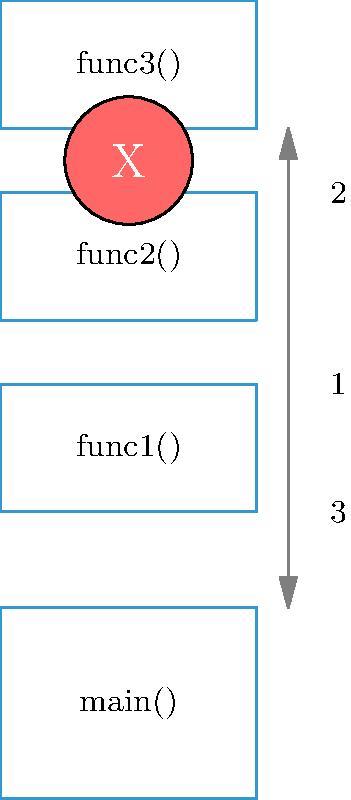In the context of exception handling and stack unwinding, analyze the vector diagram provided. Which statement best describes the process illustrated?

A) The exception is caught and handled in func1()
B) The stack unwinds from func3() directly to main()
C) The exception propagates through func2() and func1() before being caught
D) Stack unwinding occurs, but the exception remains unhandled To understand the stack unwinding process during exception handling as illustrated in the diagram, let's break it down step-by-step:

1. The diagram shows a call stack with four functions: main(), func1(), func2(), and func3().

2. The exception (represented by the red circle with "X") occurs in func3(), which is at the top of the call stack.

3. The arrows on the right side of the diagram indicate the direction of the stack unwinding process:
   - Arrow 1 shows the initial function calls from main() to func3().
   - Arrows 2 and 3 show the stack unwinding process after the exception occurs.

4. When the exception is thrown in func3(), the stack begins to unwind. This means that the program looks for an appropriate exception handler by moving down the call stack.

5. The diagram shows that the exception propagates through func2() and func1(). This is evident from the continuous downward arrow (labeled 2) passing through these functions.

6. The stack unwinding process continues until it reaches main(), as indicated by arrow 3.

7. There is no indication in the diagram of the exception being caught and handled in any of the intermediate functions (func2() or func1()).

8. The diagram doesn't explicitly show where the exception is ultimately handled, but it demonstrates the complete unwinding of the stack back to main().

Based on this analysis, the process illustrated in the diagram shows the exception propagating through func2() and func1() before potentially being caught in main() or remaining unhandled if main() doesn't have an appropriate catch block.
Answer: C) The exception propagates through func2() and func1() before being caught 